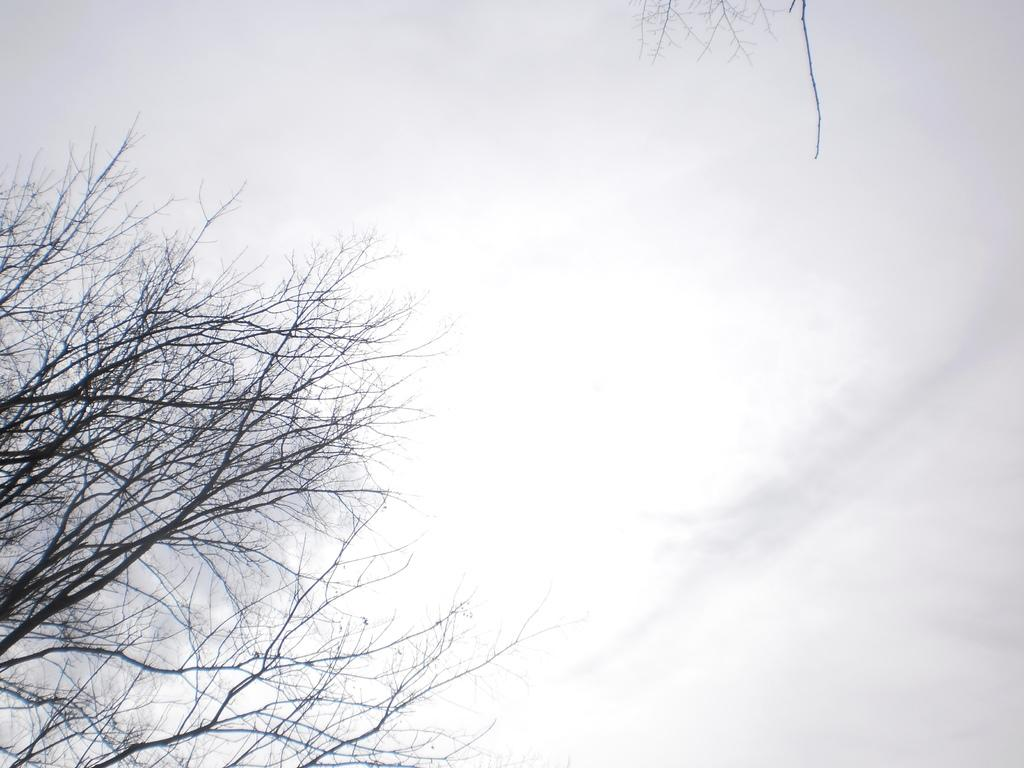What is located in the foreground of the image? There is a tree in the foreground of the image. What can be seen in the background of the image? There is sky visible in the background of the image. Are there any other trees in the image? Yes, there is another tree in the background of the image. What type of wine is being served in the image? There is no wine present in the image; it features trees and sky. What is the brick used for in the image? There is no brick present in the image. 